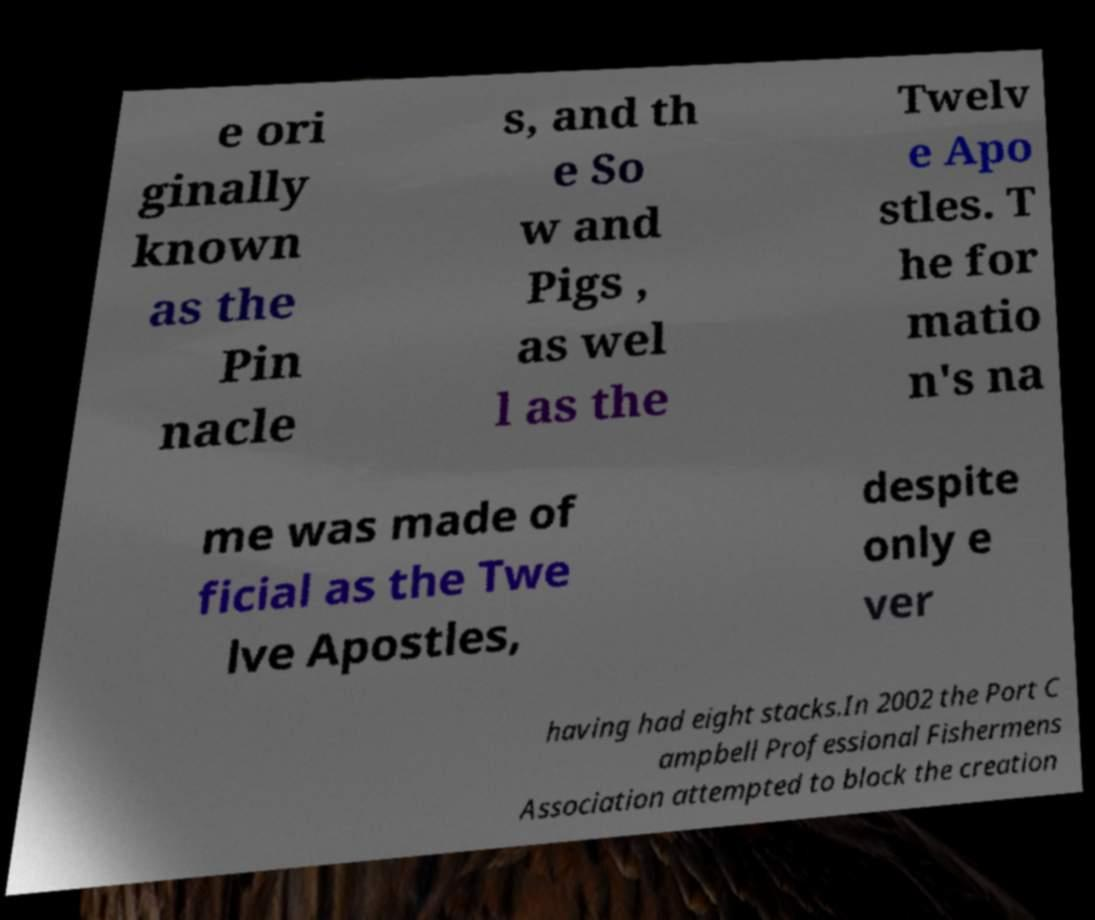I need the written content from this picture converted into text. Can you do that? e ori ginally known as the Pin nacle s, and th e So w and Pigs , as wel l as the Twelv e Apo stles. T he for matio n's na me was made of ficial as the Twe lve Apostles, despite only e ver having had eight stacks.In 2002 the Port C ampbell Professional Fishermens Association attempted to block the creation 